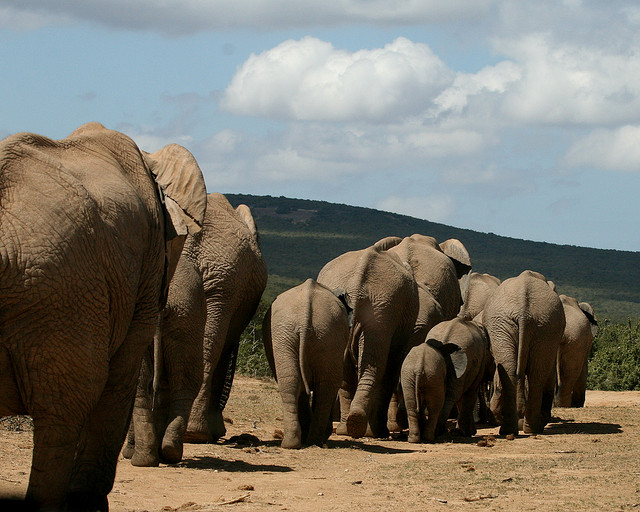<image>What part of the elephants are touching? I don't know which parts of the elephants are touching. It could be their sides, rear, trunk and tail, backs, head, or feet. What part of the elephants are touching? I don't know what part of the elephants are touching. It can be their sides, rear, trunk and tail, backs, head, or feet. 